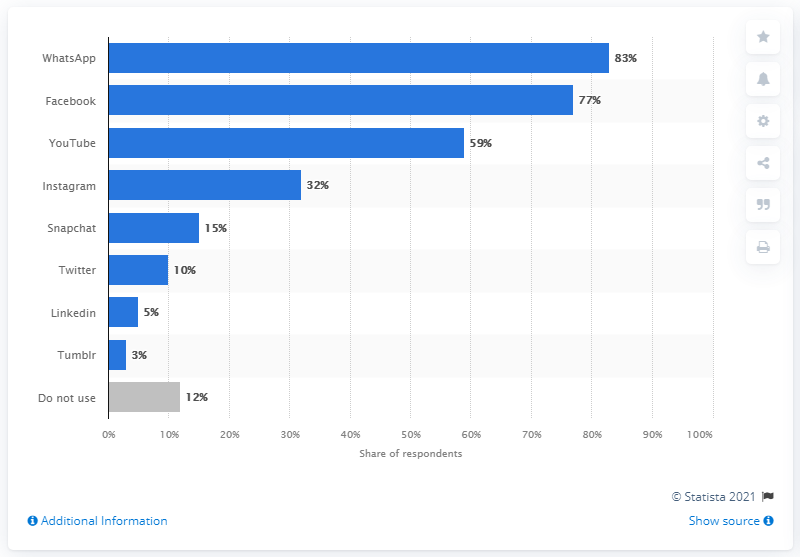Specify some key components in this picture. According to the survey, 83% of respondents stated that they are using WhatsApp, the most popular social network. 